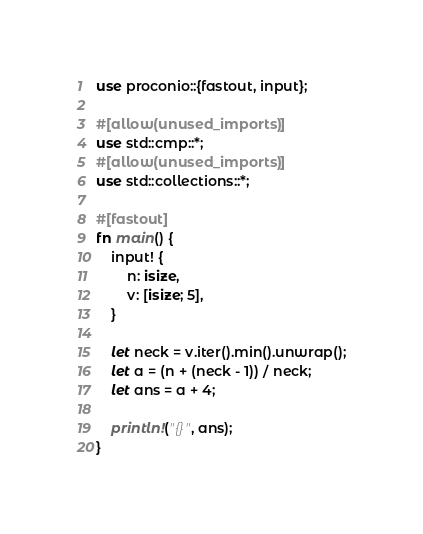Convert code to text. <code><loc_0><loc_0><loc_500><loc_500><_Rust_>use proconio::{fastout, input};

#[allow(unused_imports)]
use std::cmp::*;
#[allow(unused_imports)]
use std::collections::*;

#[fastout]
fn main() {
    input! {
        n: isize,
        v: [isize; 5],
    }

    let neck = v.iter().min().unwrap();
    let a = (n + (neck - 1)) / neck;
    let ans = a + 4;

    println!("{}", ans);
}
</code> 